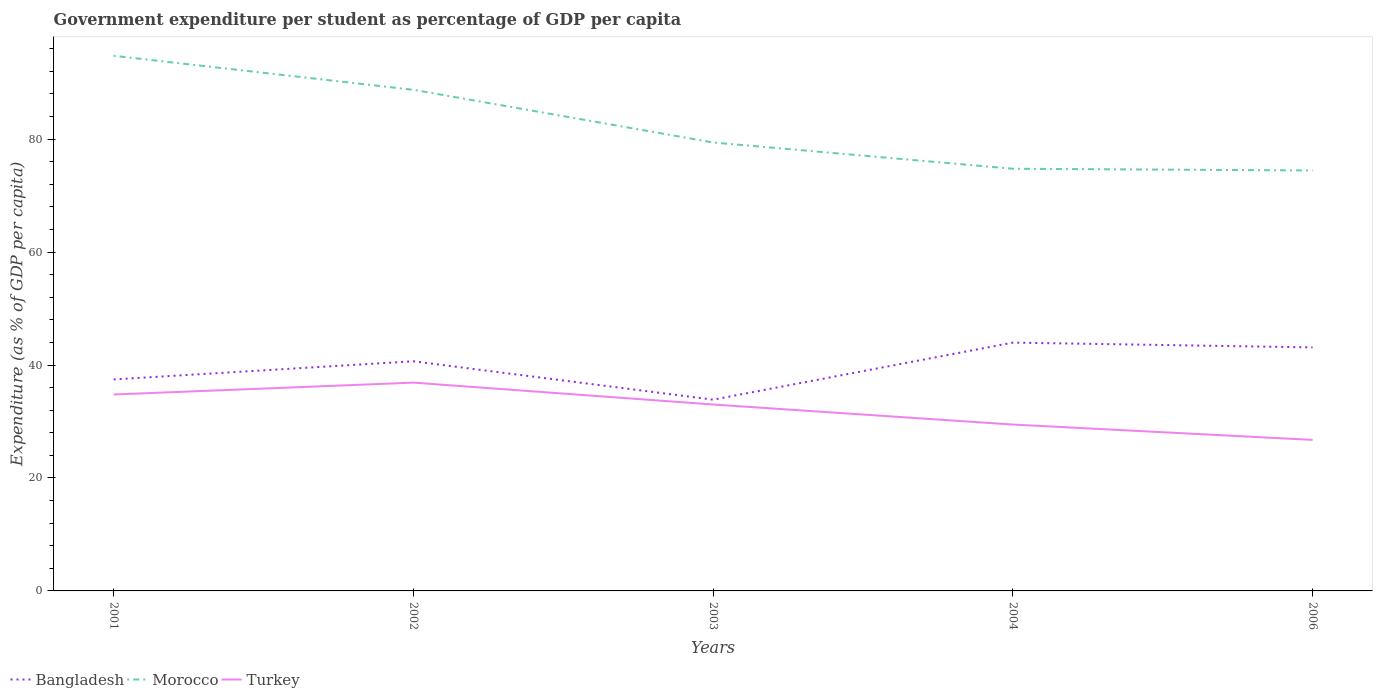How many different coloured lines are there?
Your answer should be very brief. 3. Is the number of lines equal to the number of legend labels?
Ensure brevity in your answer.  Yes. Across all years, what is the maximum percentage of expenditure per student in Turkey?
Your response must be concise. 26.74. In which year was the percentage of expenditure per student in Morocco maximum?
Offer a very short reply. 2006. What is the total percentage of expenditure per student in Bangladesh in the graph?
Your response must be concise. 0.85. What is the difference between the highest and the second highest percentage of expenditure per student in Turkey?
Ensure brevity in your answer.  10.14. What is the difference between the highest and the lowest percentage of expenditure per student in Morocco?
Your answer should be compact. 2. Is the percentage of expenditure per student in Turkey strictly greater than the percentage of expenditure per student in Bangladesh over the years?
Give a very brief answer. Yes. How many lines are there?
Offer a terse response. 3. How many years are there in the graph?
Your response must be concise. 5. Are the values on the major ticks of Y-axis written in scientific E-notation?
Make the answer very short. No. What is the title of the graph?
Provide a succinct answer. Government expenditure per student as percentage of GDP per capita. What is the label or title of the Y-axis?
Make the answer very short. Expenditure (as % of GDP per capita). What is the Expenditure (as % of GDP per capita) in Bangladesh in 2001?
Make the answer very short. 37.45. What is the Expenditure (as % of GDP per capita) of Morocco in 2001?
Give a very brief answer. 94.77. What is the Expenditure (as % of GDP per capita) in Turkey in 2001?
Your response must be concise. 34.78. What is the Expenditure (as % of GDP per capita) in Bangladesh in 2002?
Your answer should be compact. 40.67. What is the Expenditure (as % of GDP per capita) in Morocco in 2002?
Provide a succinct answer. 88.74. What is the Expenditure (as % of GDP per capita) in Turkey in 2002?
Offer a terse response. 36.89. What is the Expenditure (as % of GDP per capita) of Bangladesh in 2003?
Provide a succinct answer. 33.87. What is the Expenditure (as % of GDP per capita) in Morocco in 2003?
Your answer should be compact. 79.41. What is the Expenditure (as % of GDP per capita) of Turkey in 2003?
Keep it short and to the point. 33.01. What is the Expenditure (as % of GDP per capita) in Bangladesh in 2004?
Your answer should be compact. 43.97. What is the Expenditure (as % of GDP per capita) of Morocco in 2004?
Your response must be concise. 74.76. What is the Expenditure (as % of GDP per capita) of Turkey in 2004?
Your answer should be compact. 29.46. What is the Expenditure (as % of GDP per capita) in Bangladesh in 2006?
Provide a short and direct response. 43.12. What is the Expenditure (as % of GDP per capita) in Morocco in 2006?
Keep it short and to the point. 74.46. What is the Expenditure (as % of GDP per capita) of Turkey in 2006?
Keep it short and to the point. 26.74. Across all years, what is the maximum Expenditure (as % of GDP per capita) of Bangladesh?
Make the answer very short. 43.97. Across all years, what is the maximum Expenditure (as % of GDP per capita) of Morocco?
Keep it short and to the point. 94.77. Across all years, what is the maximum Expenditure (as % of GDP per capita) in Turkey?
Give a very brief answer. 36.89. Across all years, what is the minimum Expenditure (as % of GDP per capita) in Bangladesh?
Your answer should be very brief. 33.87. Across all years, what is the minimum Expenditure (as % of GDP per capita) of Morocco?
Provide a short and direct response. 74.46. Across all years, what is the minimum Expenditure (as % of GDP per capita) in Turkey?
Your response must be concise. 26.74. What is the total Expenditure (as % of GDP per capita) of Bangladesh in the graph?
Give a very brief answer. 199.09. What is the total Expenditure (as % of GDP per capita) in Morocco in the graph?
Make the answer very short. 412.14. What is the total Expenditure (as % of GDP per capita) of Turkey in the graph?
Keep it short and to the point. 160.89. What is the difference between the Expenditure (as % of GDP per capita) of Bangladesh in 2001 and that in 2002?
Make the answer very short. -3.21. What is the difference between the Expenditure (as % of GDP per capita) of Morocco in 2001 and that in 2002?
Make the answer very short. 6.02. What is the difference between the Expenditure (as % of GDP per capita) of Turkey in 2001 and that in 2002?
Provide a succinct answer. -2.1. What is the difference between the Expenditure (as % of GDP per capita) of Bangladesh in 2001 and that in 2003?
Provide a succinct answer. 3.59. What is the difference between the Expenditure (as % of GDP per capita) of Morocco in 2001 and that in 2003?
Provide a short and direct response. 15.35. What is the difference between the Expenditure (as % of GDP per capita) of Turkey in 2001 and that in 2003?
Offer a very short reply. 1.77. What is the difference between the Expenditure (as % of GDP per capita) of Bangladesh in 2001 and that in 2004?
Make the answer very short. -6.52. What is the difference between the Expenditure (as % of GDP per capita) in Morocco in 2001 and that in 2004?
Provide a short and direct response. 20. What is the difference between the Expenditure (as % of GDP per capita) in Turkey in 2001 and that in 2004?
Give a very brief answer. 5.32. What is the difference between the Expenditure (as % of GDP per capita) of Bangladesh in 2001 and that in 2006?
Your response must be concise. -5.67. What is the difference between the Expenditure (as % of GDP per capita) in Morocco in 2001 and that in 2006?
Keep it short and to the point. 20.31. What is the difference between the Expenditure (as % of GDP per capita) in Turkey in 2001 and that in 2006?
Keep it short and to the point. 8.04. What is the difference between the Expenditure (as % of GDP per capita) in Bangladesh in 2002 and that in 2003?
Provide a short and direct response. 6.8. What is the difference between the Expenditure (as % of GDP per capita) of Morocco in 2002 and that in 2003?
Ensure brevity in your answer.  9.33. What is the difference between the Expenditure (as % of GDP per capita) in Turkey in 2002 and that in 2003?
Offer a terse response. 3.88. What is the difference between the Expenditure (as % of GDP per capita) of Bangladesh in 2002 and that in 2004?
Offer a very short reply. -3.31. What is the difference between the Expenditure (as % of GDP per capita) of Morocco in 2002 and that in 2004?
Give a very brief answer. 13.98. What is the difference between the Expenditure (as % of GDP per capita) of Turkey in 2002 and that in 2004?
Make the answer very short. 7.42. What is the difference between the Expenditure (as % of GDP per capita) of Bangladesh in 2002 and that in 2006?
Keep it short and to the point. -2.46. What is the difference between the Expenditure (as % of GDP per capita) of Morocco in 2002 and that in 2006?
Give a very brief answer. 14.28. What is the difference between the Expenditure (as % of GDP per capita) of Turkey in 2002 and that in 2006?
Give a very brief answer. 10.14. What is the difference between the Expenditure (as % of GDP per capita) of Bangladesh in 2003 and that in 2004?
Offer a terse response. -10.11. What is the difference between the Expenditure (as % of GDP per capita) in Morocco in 2003 and that in 2004?
Ensure brevity in your answer.  4.65. What is the difference between the Expenditure (as % of GDP per capita) in Turkey in 2003 and that in 2004?
Your response must be concise. 3.55. What is the difference between the Expenditure (as % of GDP per capita) of Bangladesh in 2003 and that in 2006?
Your answer should be very brief. -9.26. What is the difference between the Expenditure (as % of GDP per capita) in Morocco in 2003 and that in 2006?
Keep it short and to the point. 4.96. What is the difference between the Expenditure (as % of GDP per capita) of Turkey in 2003 and that in 2006?
Offer a very short reply. 6.27. What is the difference between the Expenditure (as % of GDP per capita) of Bangladesh in 2004 and that in 2006?
Offer a very short reply. 0.85. What is the difference between the Expenditure (as % of GDP per capita) of Morocco in 2004 and that in 2006?
Make the answer very short. 0.3. What is the difference between the Expenditure (as % of GDP per capita) in Turkey in 2004 and that in 2006?
Your response must be concise. 2.72. What is the difference between the Expenditure (as % of GDP per capita) in Bangladesh in 2001 and the Expenditure (as % of GDP per capita) in Morocco in 2002?
Your response must be concise. -51.29. What is the difference between the Expenditure (as % of GDP per capita) in Bangladesh in 2001 and the Expenditure (as % of GDP per capita) in Turkey in 2002?
Provide a short and direct response. 0.57. What is the difference between the Expenditure (as % of GDP per capita) in Morocco in 2001 and the Expenditure (as % of GDP per capita) in Turkey in 2002?
Your answer should be compact. 57.88. What is the difference between the Expenditure (as % of GDP per capita) of Bangladesh in 2001 and the Expenditure (as % of GDP per capita) of Morocco in 2003?
Ensure brevity in your answer.  -41.96. What is the difference between the Expenditure (as % of GDP per capita) of Bangladesh in 2001 and the Expenditure (as % of GDP per capita) of Turkey in 2003?
Ensure brevity in your answer.  4.45. What is the difference between the Expenditure (as % of GDP per capita) in Morocco in 2001 and the Expenditure (as % of GDP per capita) in Turkey in 2003?
Your answer should be very brief. 61.76. What is the difference between the Expenditure (as % of GDP per capita) of Bangladesh in 2001 and the Expenditure (as % of GDP per capita) of Morocco in 2004?
Provide a succinct answer. -37.31. What is the difference between the Expenditure (as % of GDP per capita) of Bangladesh in 2001 and the Expenditure (as % of GDP per capita) of Turkey in 2004?
Offer a very short reply. 7.99. What is the difference between the Expenditure (as % of GDP per capita) in Morocco in 2001 and the Expenditure (as % of GDP per capita) in Turkey in 2004?
Offer a terse response. 65.3. What is the difference between the Expenditure (as % of GDP per capita) in Bangladesh in 2001 and the Expenditure (as % of GDP per capita) in Morocco in 2006?
Offer a terse response. -37. What is the difference between the Expenditure (as % of GDP per capita) in Bangladesh in 2001 and the Expenditure (as % of GDP per capita) in Turkey in 2006?
Offer a very short reply. 10.71. What is the difference between the Expenditure (as % of GDP per capita) in Morocco in 2001 and the Expenditure (as % of GDP per capita) in Turkey in 2006?
Give a very brief answer. 68.02. What is the difference between the Expenditure (as % of GDP per capita) of Bangladesh in 2002 and the Expenditure (as % of GDP per capita) of Morocco in 2003?
Keep it short and to the point. -38.75. What is the difference between the Expenditure (as % of GDP per capita) in Bangladesh in 2002 and the Expenditure (as % of GDP per capita) in Turkey in 2003?
Provide a short and direct response. 7.66. What is the difference between the Expenditure (as % of GDP per capita) of Morocco in 2002 and the Expenditure (as % of GDP per capita) of Turkey in 2003?
Provide a short and direct response. 55.73. What is the difference between the Expenditure (as % of GDP per capita) in Bangladesh in 2002 and the Expenditure (as % of GDP per capita) in Morocco in 2004?
Provide a succinct answer. -34.09. What is the difference between the Expenditure (as % of GDP per capita) of Bangladesh in 2002 and the Expenditure (as % of GDP per capita) of Turkey in 2004?
Provide a short and direct response. 11.2. What is the difference between the Expenditure (as % of GDP per capita) in Morocco in 2002 and the Expenditure (as % of GDP per capita) in Turkey in 2004?
Offer a terse response. 59.28. What is the difference between the Expenditure (as % of GDP per capita) in Bangladesh in 2002 and the Expenditure (as % of GDP per capita) in Morocco in 2006?
Keep it short and to the point. -33.79. What is the difference between the Expenditure (as % of GDP per capita) in Bangladesh in 2002 and the Expenditure (as % of GDP per capita) in Turkey in 2006?
Your response must be concise. 13.92. What is the difference between the Expenditure (as % of GDP per capita) in Morocco in 2002 and the Expenditure (as % of GDP per capita) in Turkey in 2006?
Provide a succinct answer. 62. What is the difference between the Expenditure (as % of GDP per capita) in Bangladesh in 2003 and the Expenditure (as % of GDP per capita) in Morocco in 2004?
Provide a succinct answer. -40.89. What is the difference between the Expenditure (as % of GDP per capita) of Bangladesh in 2003 and the Expenditure (as % of GDP per capita) of Turkey in 2004?
Ensure brevity in your answer.  4.4. What is the difference between the Expenditure (as % of GDP per capita) in Morocco in 2003 and the Expenditure (as % of GDP per capita) in Turkey in 2004?
Ensure brevity in your answer.  49.95. What is the difference between the Expenditure (as % of GDP per capita) of Bangladesh in 2003 and the Expenditure (as % of GDP per capita) of Morocco in 2006?
Provide a short and direct response. -40.59. What is the difference between the Expenditure (as % of GDP per capita) of Bangladesh in 2003 and the Expenditure (as % of GDP per capita) of Turkey in 2006?
Provide a succinct answer. 7.12. What is the difference between the Expenditure (as % of GDP per capita) of Morocco in 2003 and the Expenditure (as % of GDP per capita) of Turkey in 2006?
Keep it short and to the point. 52.67. What is the difference between the Expenditure (as % of GDP per capita) of Bangladesh in 2004 and the Expenditure (as % of GDP per capita) of Morocco in 2006?
Keep it short and to the point. -30.48. What is the difference between the Expenditure (as % of GDP per capita) of Bangladesh in 2004 and the Expenditure (as % of GDP per capita) of Turkey in 2006?
Make the answer very short. 17.23. What is the difference between the Expenditure (as % of GDP per capita) of Morocco in 2004 and the Expenditure (as % of GDP per capita) of Turkey in 2006?
Offer a very short reply. 48.02. What is the average Expenditure (as % of GDP per capita) of Bangladesh per year?
Provide a short and direct response. 39.82. What is the average Expenditure (as % of GDP per capita) of Morocco per year?
Give a very brief answer. 82.43. What is the average Expenditure (as % of GDP per capita) of Turkey per year?
Offer a terse response. 32.18. In the year 2001, what is the difference between the Expenditure (as % of GDP per capita) of Bangladesh and Expenditure (as % of GDP per capita) of Morocco?
Give a very brief answer. -57.31. In the year 2001, what is the difference between the Expenditure (as % of GDP per capita) in Bangladesh and Expenditure (as % of GDP per capita) in Turkey?
Your response must be concise. 2.67. In the year 2001, what is the difference between the Expenditure (as % of GDP per capita) in Morocco and Expenditure (as % of GDP per capita) in Turkey?
Your response must be concise. 59.98. In the year 2002, what is the difference between the Expenditure (as % of GDP per capita) in Bangladesh and Expenditure (as % of GDP per capita) in Morocco?
Provide a short and direct response. -48.07. In the year 2002, what is the difference between the Expenditure (as % of GDP per capita) in Bangladesh and Expenditure (as % of GDP per capita) in Turkey?
Offer a terse response. 3.78. In the year 2002, what is the difference between the Expenditure (as % of GDP per capita) of Morocco and Expenditure (as % of GDP per capita) of Turkey?
Provide a succinct answer. 51.85. In the year 2003, what is the difference between the Expenditure (as % of GDP per capita) in Bangladesh and Expenditure (as % of GDP per capita) in Morocco?
Make the answer very short. -45.55. In the year 2003, what is the difference between the Expenditure (as % of GDP per capita) in Bangladesh and Expenditure (as % of GDP per capita) in Turkey?
Your answer should be very brief. 0.86. In the year 2003, what is the difference between the Expenditure (as % of GDP per capita) of Morocco and Expenditure (as % of GDP per capita) of Turkey?
Your response must be concise. 46.4. In the year 2004, what is the difference between the Expenditure (as % of GDP per capita) in Bangladesh and Expenditure (as % of GDP per capita) in Morocco?
Keep it short and to the point. -30.79. In the year 2004, what is the difference between the Expenditure (as % of GDP per capita) of Bangladesh and Expenditure (as % of GDP per capita) of Turkey?
Ensure brevity in your answer.  14.51. In the year 2004, what is the difference between the Expenditure (as % of GDP per capita) of Morocco and Expenditure (as % of GDP per capita) of Turkey?
Give a very brief answer. 45.3. In the year 2006, what is the difference between the Expenditure (as % of GDP per capita) of Bangladesh and Expenditure (as % of GDP per capita) of Morocco?
Make the answer very short. -31.33. In the year 2006, what is the difference between the Expenditure (as % of GDP per capita) in Bangladesh and Expenditure (as % of GDP per capita) in Turkey?
Offer a terse response. 16.38. In the year 2006, what is the difference between the Expenditure (as % of GDP per capita) in Morocco and Expenditure (as % of GDP per capita) in Turkey?
Keep it short and to the point. 47.71. What is the ratio of the Expenditure (as % of GDP per capita) in Bangladesh in 2001 to that in 2002?
Your response must be concise. 0.92. What is the ratio of the Expenditure (as % of GDP per capita) in Morocco in 2001 to that in 2002?
Make the answer very short. 1.07. What is the ratio of the Expenditure (as % of GDP per capita) of Turkey in 2001 to that in 2002?
Provide a short and direct response. 0.94. What is the ratio of the Expenditure (as % of GDP per capita) of Bangladesh in 2001 to that in 2003?
Offer a very short reply. 1.11. What is the ratio of the Expenditure (as % of GDP per capita) of Morocco in 2001 to that in 2003?
Provide a succinct answer. 1.19. What is the ratio of the Expenditure (as % of GDP per capita) of Turkey in 2001 to that in 2003?
Your answer should be compact. 1.05. What is the ratio of the Expenditure (as % of GDP per capita) in Bangladesh in 2001 to that in 2004?
Keep it short and to the point. 0.85. What is the ratio of the Expenditure (as % of GDP per capita) in Morocco in 2001 to that in 2004?
Offer a very short reply. 1.27. What is the ratio of the Expenditure (as % of GDP per capita) of Turkey in 2001 to that in 2004?
Give a very brief answer. 1.18. What is the ratio of the Expenditure (as % of GDP per capita) in Bangladesh in 2001 to that in 2006?
Your answer should be very brief. 0.87. What is the ratio of the Expenditure (as % of GDP per capita) of Morocco in 2001 to that in 2006?
Keep it short and to the point. 1.27. What is the ratio of the Expenditure (as % of GDP per capita) in Turkey in 2001 to that in 2006?
Offer a terse response. 1.3. What is the ratio of the Expenditure (as % of GDP per capita) in Bangladesh in 2002 to that in 2003?
Keep it short and to the point. 1.2. What is the ratio of the Expenditure (as % of GDP per capita) in Morocco in 2002 to that in 2003?
Your response must be concise. 1.12. What is the ratio of the Expenditure (as % of GDP per capita) of Turkey in 2002 to that in 2003?
Your answer should be compact. 1.12. What is the ratio of the Expenditure (as % of GDP per capita) in Bangladesh in 2002 to that in 2004?
Offer a very short reply. 0.92. What is the ratio of the Expenditure (as % of GDP per capita) of Morocco in 2002 to that in 2004?
Keep it short and to the point. 1.19. What is the ratio of the Expenditure (as % of GDP per capita) in Turkey in 2002 to that in 2004?
Your answer should be compact. 1.25. What is the ratio of the Expenditure (as % of GDP per capita) in Bangladesh in 2002 to that in 2006?
Your response must be concise. 0.94. What is the ratio of the Expenditure (as % of GDP per capita) of Morocco in 2002 to that in 2006?
Give a very brief answer. 1.19. What is the ratio of the Expenditure (as % of GDP per capita) of Turkey in 2002 to that in 2006?
Your answer should be very brief. 1.38. What is the ratio of the Expenditure (as % of GDP per capita) of Bangladesh in 2003 to that in 2004?
Provide a short and direct response. 0.77. What is the ratio of the Expenditure (as % of GDP per capita) of Morocco in 2003 to that in 2004?
Give a very brief answer. 1.06. What is the ratio of the Expenditure (as % of GDP per capita) of Turkey in 2003 to that in 2004?
Provide a short and direct response. 1.12. What is the ratio of the Expenditure (as % of GDP per capita) in Bangladesh in 2003 to that in 2006?
Keep it short and to the point. 0.79. What is the ratio of the Expenditure (as % of GDP per capita) of Morocco in 2003 to that in 2006?
Your answer should be very brief. 1.07. What is the ratio of the Expenditure (as % of GDP per capita) of Turkey in 2003 to that in 2006?
Give a very brief answer. 1.23. What is the ratio of the Expenditure (as % of GDP per capita) of Bangladesh in 2004 to that in 2006?
Give a very brief answer. 1.02. What is the ratio of the Expenditure (as % of GDP per capita) in Turkey in 2004 to that in 2006?
Offer a very short reply. 1.1. What is the difference between the highest and the second highest Expenditure (as % of GDP per capita) of Bangladesh?
Your response must be concise. 0.85. What is the difference between the highest and the second highest Expenditure (as % of GDP per capita) of Morocco?
Offer a terse response. 6.02. What is the difference between the highest and the second highest Expenditure (as % of GDP per capita) of Turkey?
Give a very brief answer. 2.1. What is the difference between the highest and the lowest Expenditure (as % of GDP per capita) of Bangladesh?
Your response must be concise. 10.11. What is the difference between the highest and the lowest Expenditure (as % of GDP per capita) of Morocco?
Your answer should be compact. 20.31. What is the difference between the highest and the lowest Expenditure (as % of GDP per capita) of Turkey?
Provide a short and direct response. 10.14. 